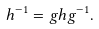<formula> <loc_0><loc_0><loc_500><loc_500>h ^ { - 1 } = g h g ^ { - 1 } .</formula> 